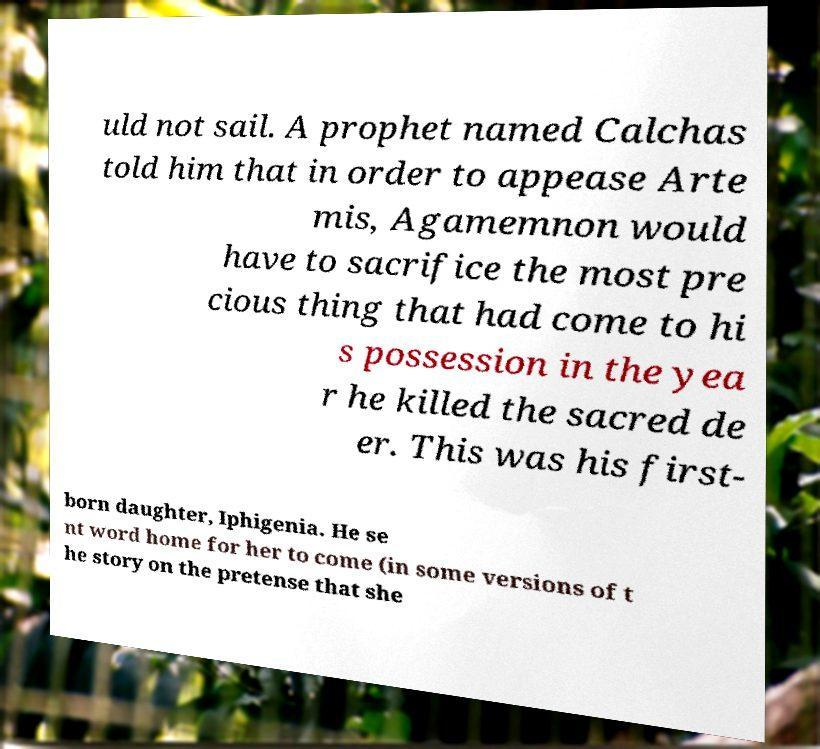What messages or text are displayed in this image? I need them in a readable, typed format. uld not sail. A prophet named Calchas told him that in order to appease Arte mis, Agamemnon would have to sacrifice the most pre cious thing that had come to hi s possession in the yea r he killed the sacred de er. This was his first- born daughter, Iphigenia. He se nt word home for her to come (in some versions of t he story on the pretense that she 